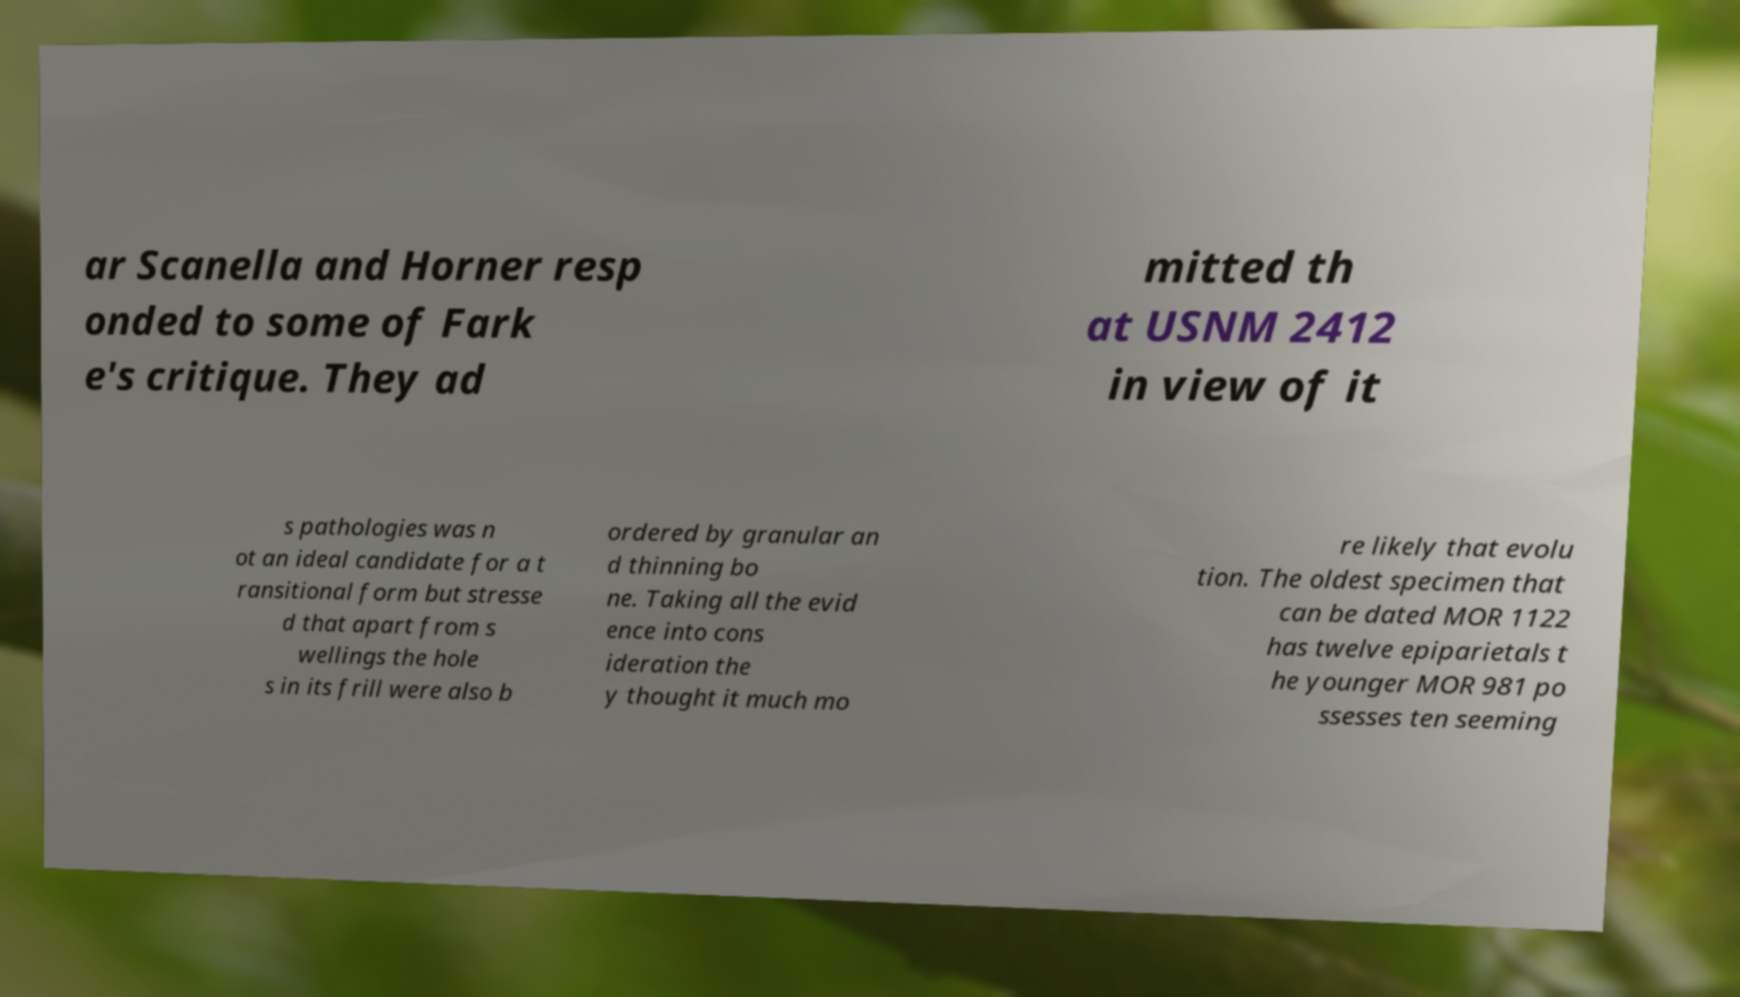Can you read and provide the text displayed in the image?This photo seems to have some interesting text. Can you extract and type it out for me? ar Scanella and Horner resp onded to some of Fark e's critique. They ad mitted th at USNM 2412 in view of it s pathologies was n ot an ideal candidate for a t ransitional form but stresse d that apart from s wellings the hole s in its frill were also b ordered by granular an d thinning bo ne. Taking all the evid ence into cons ideration the y thought it much mo re likely that evolu tion. The oldest specimen that can be dated MOR 1122 has twelve epiparietals t he younger MOR 981 po ssesses ten seeming 